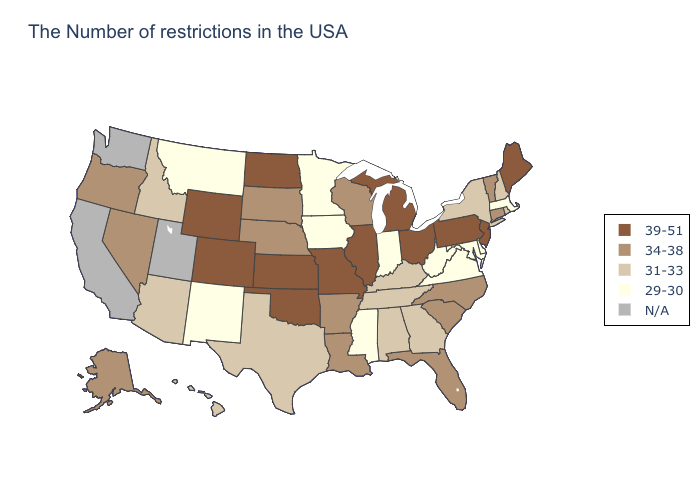Does Pennsylvania have the lowest value in the USA?
Write a very short answer. No. Does the first symbol in the legend represent the smallest category?
Keep it brief. No. Does the map have missing data?
Keep it brief. Yes. Does Georgia have the lowest value in the South?
Quick response, please. No. Name the states that have a value in the range 29-30?
Quick response, please. Massachusetts, Delaware, Maryland, Virginia, West Virginia, Indiana, Mississippi, Minnesota, Iowa, New Mexico, Montana. Which states have the lowest value in the West?
Quick response, please. New Mexico, Montana. Name the states that have a value in the range 39-51?
Write a very short answer. Maine, New Jersey, Pennsylvania, Ohio, Michigan, Illinois, Missouri, Kansas, Oklahoma, North Dakota, Wyoming, Colorado. Name the states that have a value in the range N/A?
Short answer required. Utah, California, Washington. Name the states that have a value in the range 34-38?
Answer briefly. Vermont, Connecticut, North Carolina, South Carolina, Florida, Wisconsin, Louisiana, Arkansas, Nebraska, South Dakota, Nevada, Oregon, Alaska. Does Iowa have the lowest value in the MidWest?
Quick response, please. Yes. Does the first symbol in the legend represent the smallest category?
Short answer required. No. What is the lowest value in the USA?
Concise answer only. 29-30. Name the states that have a value in the range 29-30?
Quick response, please. Massachusetts, Delaware, Maryland, Virginia, West Virginia, Indiana, Mississippi, Minnesota, Iowa, New Mexico, Montana. Which states have the lowest value in the USA?
Concise answer only. Massachusetts, Delaware, Maryland, Virginia, West Virginia, Indiana, Mississippi, Minnesota, Iowa, New Mexico, Montana. Among the states that border North Dakota , does Montana have the highest value?
Give a very brief answer. No. 